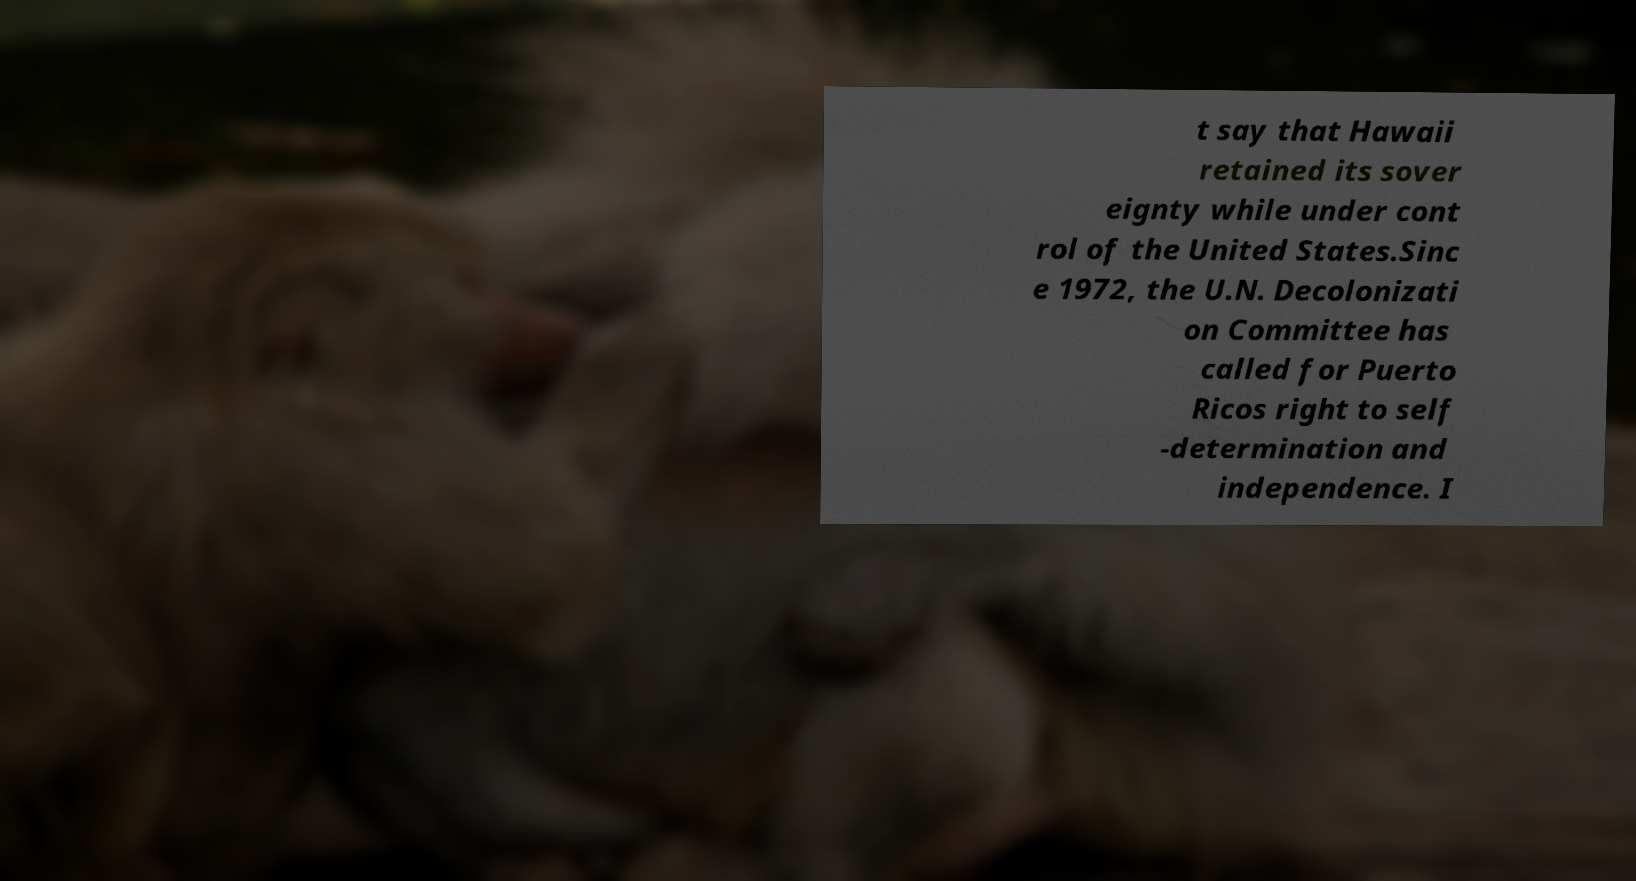Could you extract and type out the text from this image? t say that Hawaii retained its sover eignty while under cont rol of the United States.Sinc e 1972, the U.N. Decolonizati on Committee has called for Puerto Ricos right to self -determination and independence. I 